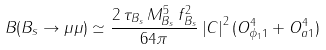<formula> <loc_0><loc_0><loc_500><loc_500>B ( B _ { s } \rightarrow \mu \mu ) \simeq \frac { 2 \, \tau _ { B _ { s } } \, M _ { B _ { s } } ^ { 5 } \, f _ { B _ { s } } ^ { 2 } } { 6 4 \pi } \left | C \right | ^ { 2 } ( O _ { \phi _ { 1 } 1 } ^ { 4 } + O _ { a 1 } ^ { 4 } )</formula> 